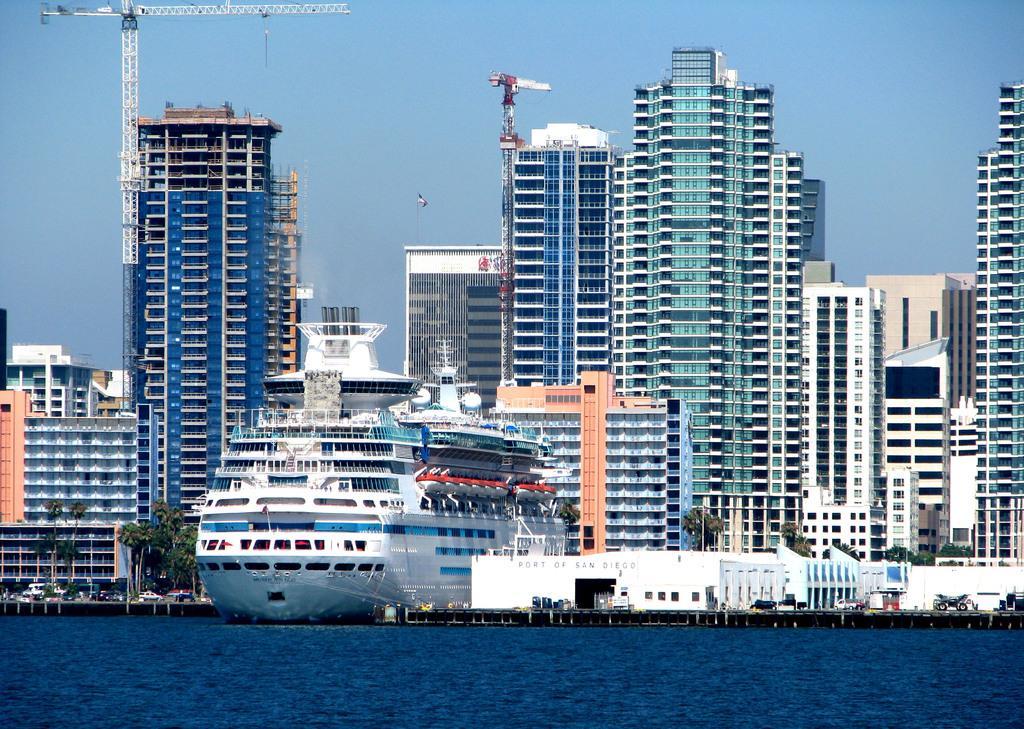Describe this image in one or two sentences. In this image I can see the water, a ship which is white, blue and red in color on the surface of the water, few trees which are green in color, few vehicles and few buildings. In the background I can see few cranes and the sky. 